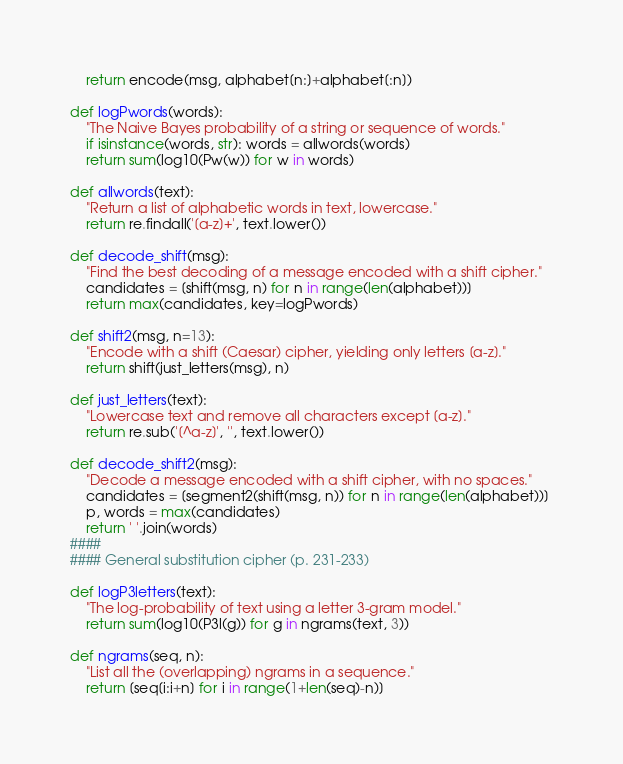<code> <loc_0><loc_0><loc_500><loc_500><_Python_>    return encode(msg, alphabet[n:]+alphabet[:n]) 

def logPwords(words): 
    "The Naive Bayes probability of a string or sequence of words." 
    if isinstance(words, str): words = allwords(words) 
    return sum(log10(Pw(w)) for w in words) 

def allwords(text): 
    "Return a list of alphabetic words in text, lowercase." 
    return re.findall('[a-z]+', text.lower()) 

def decode_shift(msg): 
    "Find the best decoding of a message encoded with a shift cipher." 
    candidates = [shift(msg, n) for n in range(len(alphabet))] 
    return max(candidates, key=logPwords) 

def shift2(msg, n=13): 
    "Encode with a shift (Caesar) cipher, yielding only letters [a-z]." 
    return shift(just_letters(msg), n) 

def just_letters(text): 
    "Lowercase text and remove all characters except [a-z]." 
    return re.sub('[^a-z]', '', text.lower()) 

def decode_shift2(msg): 
    "Decode a message encoded with a shift cipher, with no spaces." 
    candidates = [segment2(shift(msg, n)) for n in range(len(alphabet))] 
    p, words = max(candidates) 
    return ' '.join(words) 
####
#### General substitution cipher (p. 231-233)

def logP3letters(text): 
    "The log-probability of text using a letter 3-gram model." 
    return sum(log10(P3l(g)) for g in ngrams(text, 3)) 

def ngrams(seq, n):
    "List all the (overlapping) ngrams in a sequence."
    return [seq[i:i+n] for i in range(1+len(seq)-n)]
</code> 